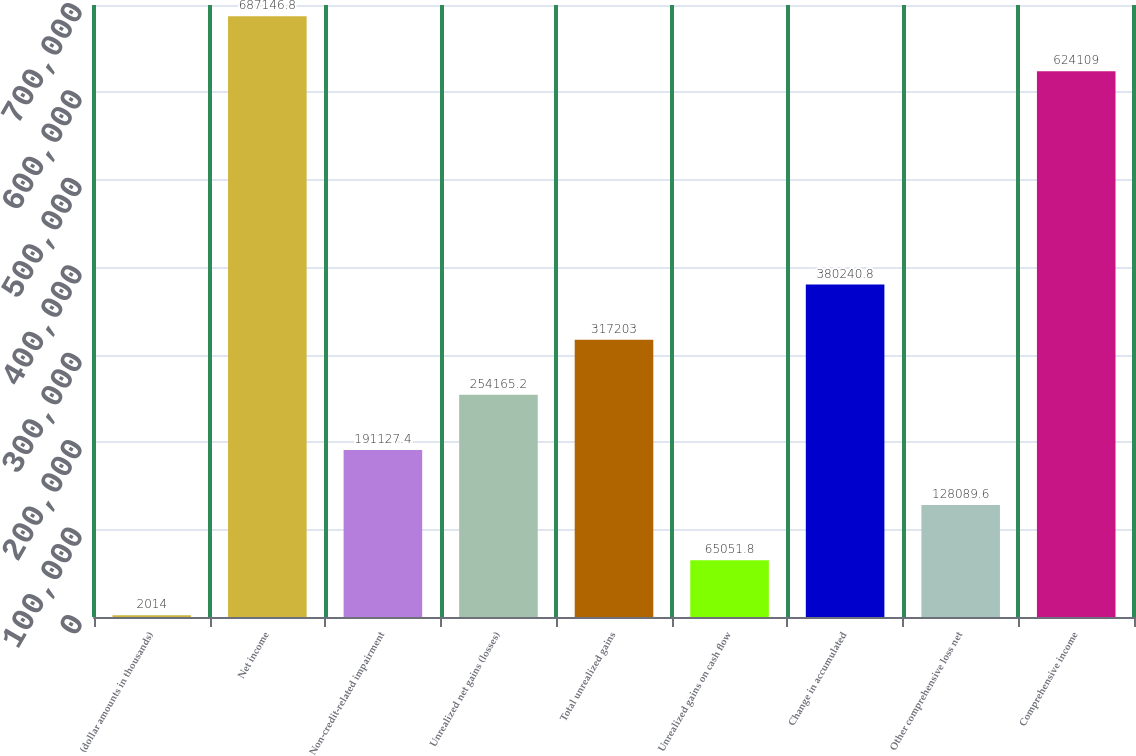<chart> <loc_0><loc_0><loc_500><loc_500><bar_chart><fcel>(dollar amounts in thousands)<fcel>Net income<fcel>Non-credit-related impairment<fcel>Unrealized net gains (losses)<fcel>Total unrealized gains<fcel>Unrealized gains on cash flow<fcel>Change in accumulated<fcel>Other comprehensive loss net<fcel>Comprehensive income<nl><fcel>2014<fcel>687147<fcel>191127<fcel>254165<fcel>317203<fcel>65051.8<fcel>380241<fcel>128090<fcel>624109<nl></chart> 